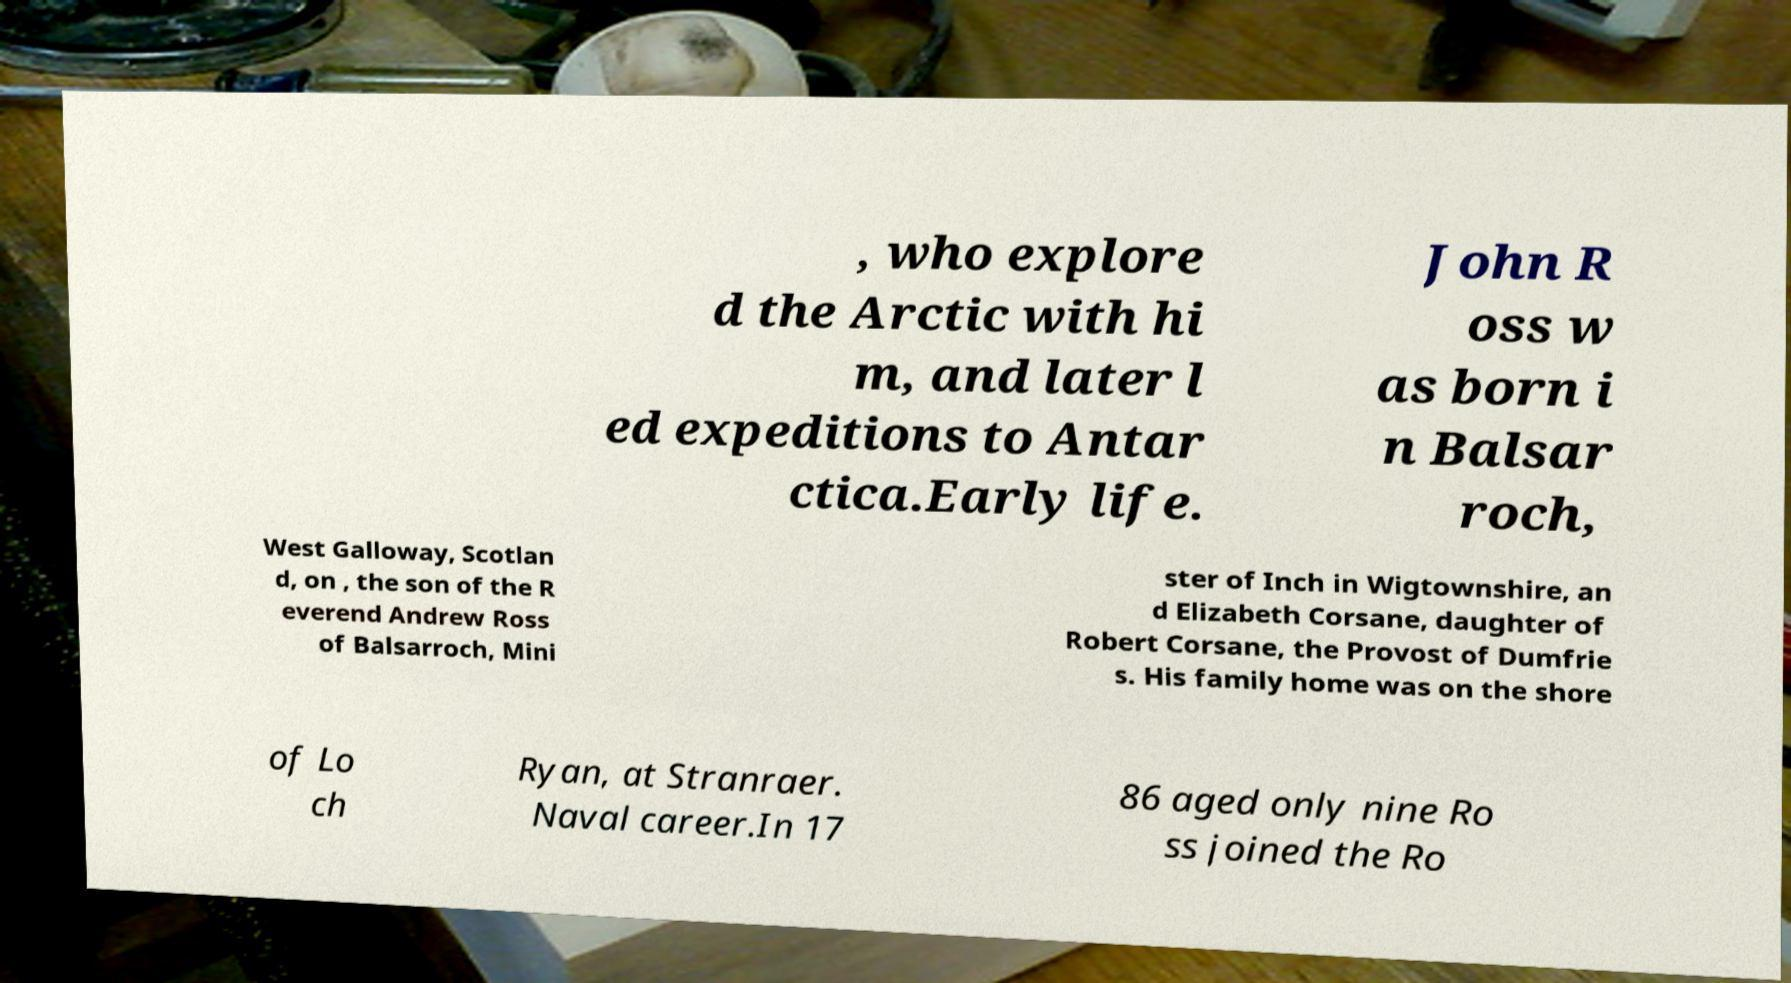Could you extract and type out the text from this image? , who explore d the Arctic with hi m, and later l ed expeditions to Antar ctica.Early life. John R oss w as born i n Balsar roch, West Galloway, Scotlan d, on , the son of the R everend Andrew Ross of Balsarroch, Mini ster of Inch in Wigtownshire, an d Elizabeth Corsane, daughter of Robert Corsane, the Provost of Dumfrie s. His family home was on the shore of Lo ch Ryan, at Stranraer. Naval career.In 17 86 aged only nine Ro ss joined the Ro 